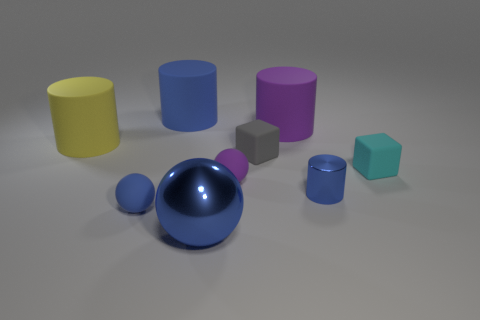Subtract all cylinders. How many objects are left? 5 Add 8 small cubes. How many small cubes exist? 10 Subtract 1 cyan blocks. How many objects are left? 8 Subtract all big cylinders. Subtract all big blue objects. How many objects are left? 4 Add 1 blue rubber balls. How many blue rubber balls are left? 2 